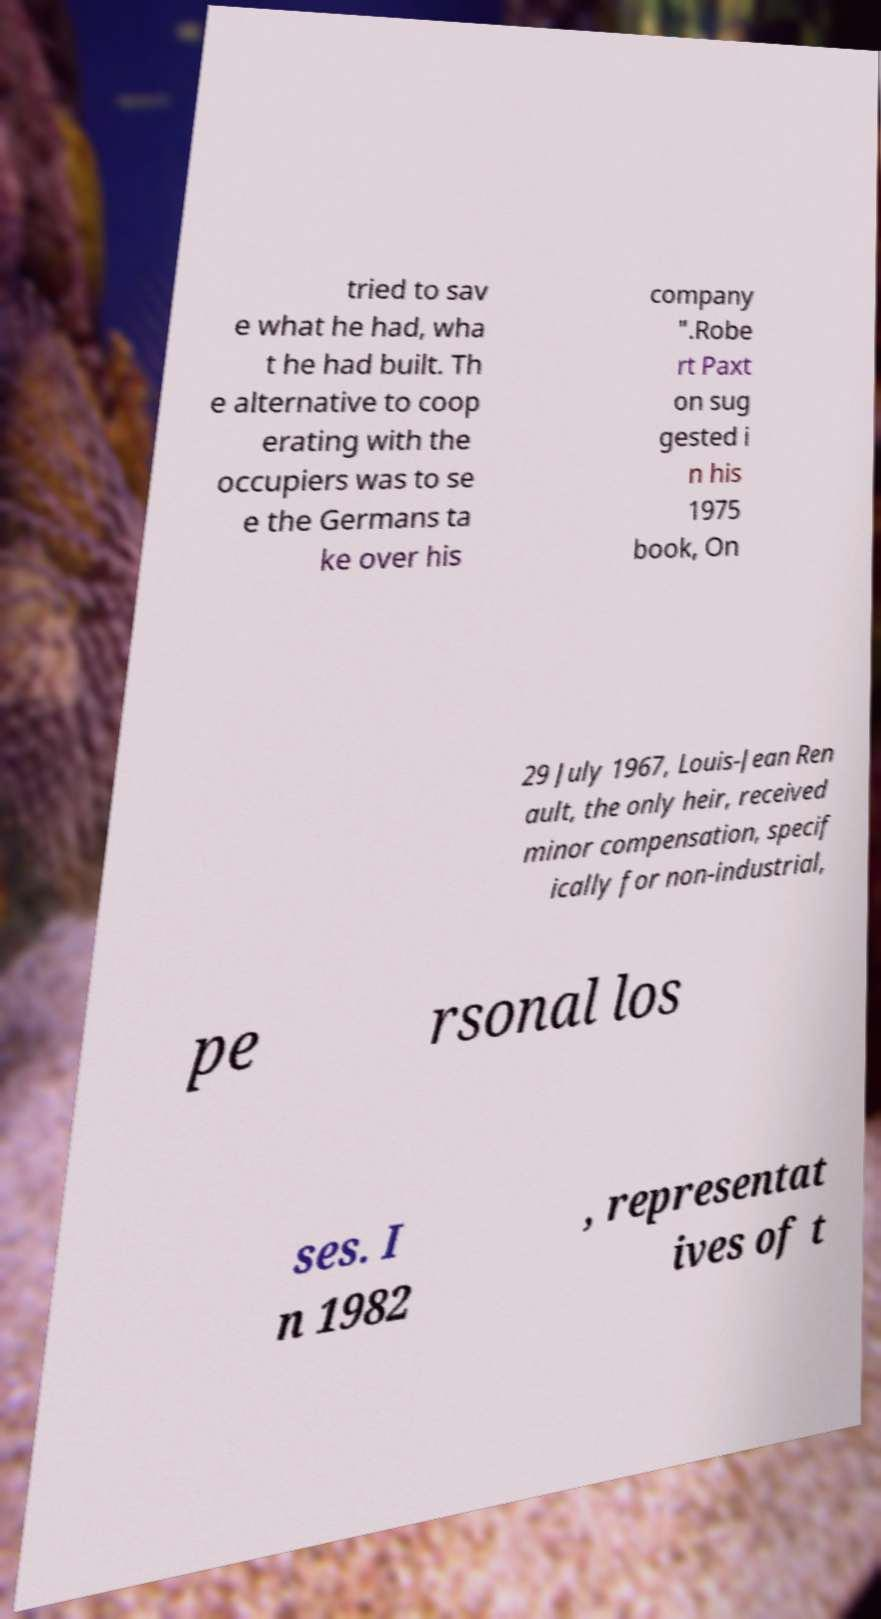For documentation purposes, I need the text within this image transcribed. Could you provide that? tried to sav e what he had, wha t he had built. Th e alternative to coop erating with the occupiers was to se e the Germans ta ke over his company ".Robe rt Paxt on sug gested i n his 1975 book, On 29 July 1967, Louis-Jean Ren ault, the only heir, received minor compensation, specif ically for non-industrial, pe rsonal los ses. I n 1982 , representat ives of t 